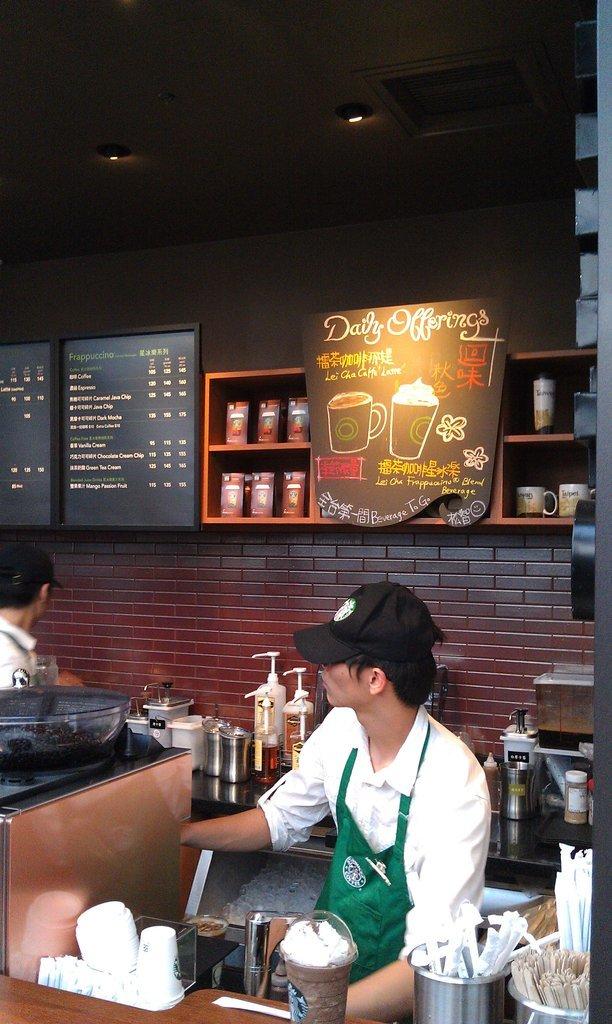What kind of offering is on the board?
Provide a short and direct response. Daily. What kind of coffee do they sell?
Provide a succinct answer. Starbucks. 